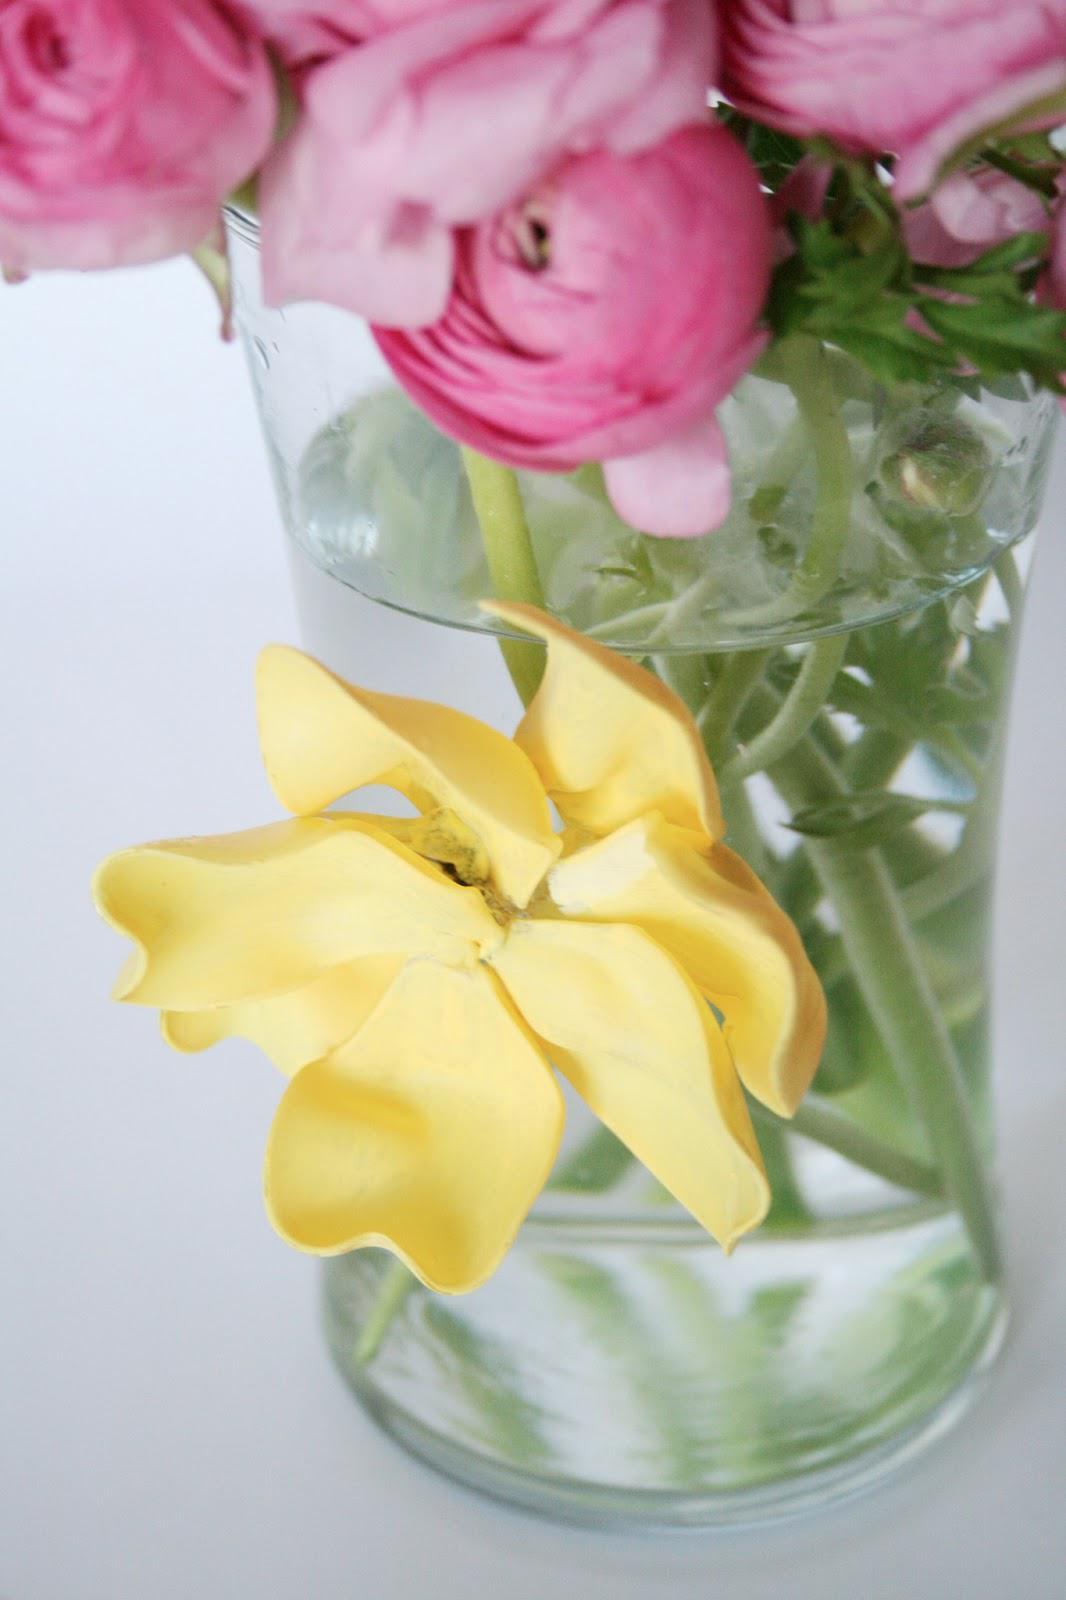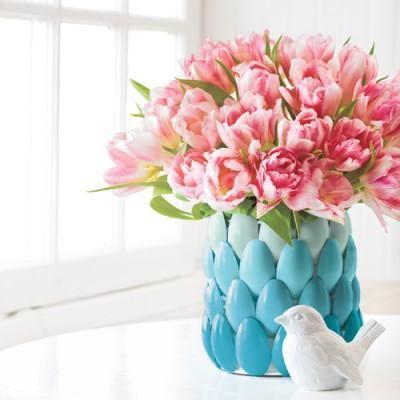The first image is the image on the left, the second image is the image on the right. Given the left and right images, does the statement "The vase on the left contains all pink flowers, while the vase on the right contains at least some purple flowers." hold true? Answer yes or no. No. The first image is the image on the left, the second image is the image on the right. Assess this claim about the two images: "The left image features a square vase displayed head-on that holds only dark pink roses.". Correct or not? Answer yes or no. No. 